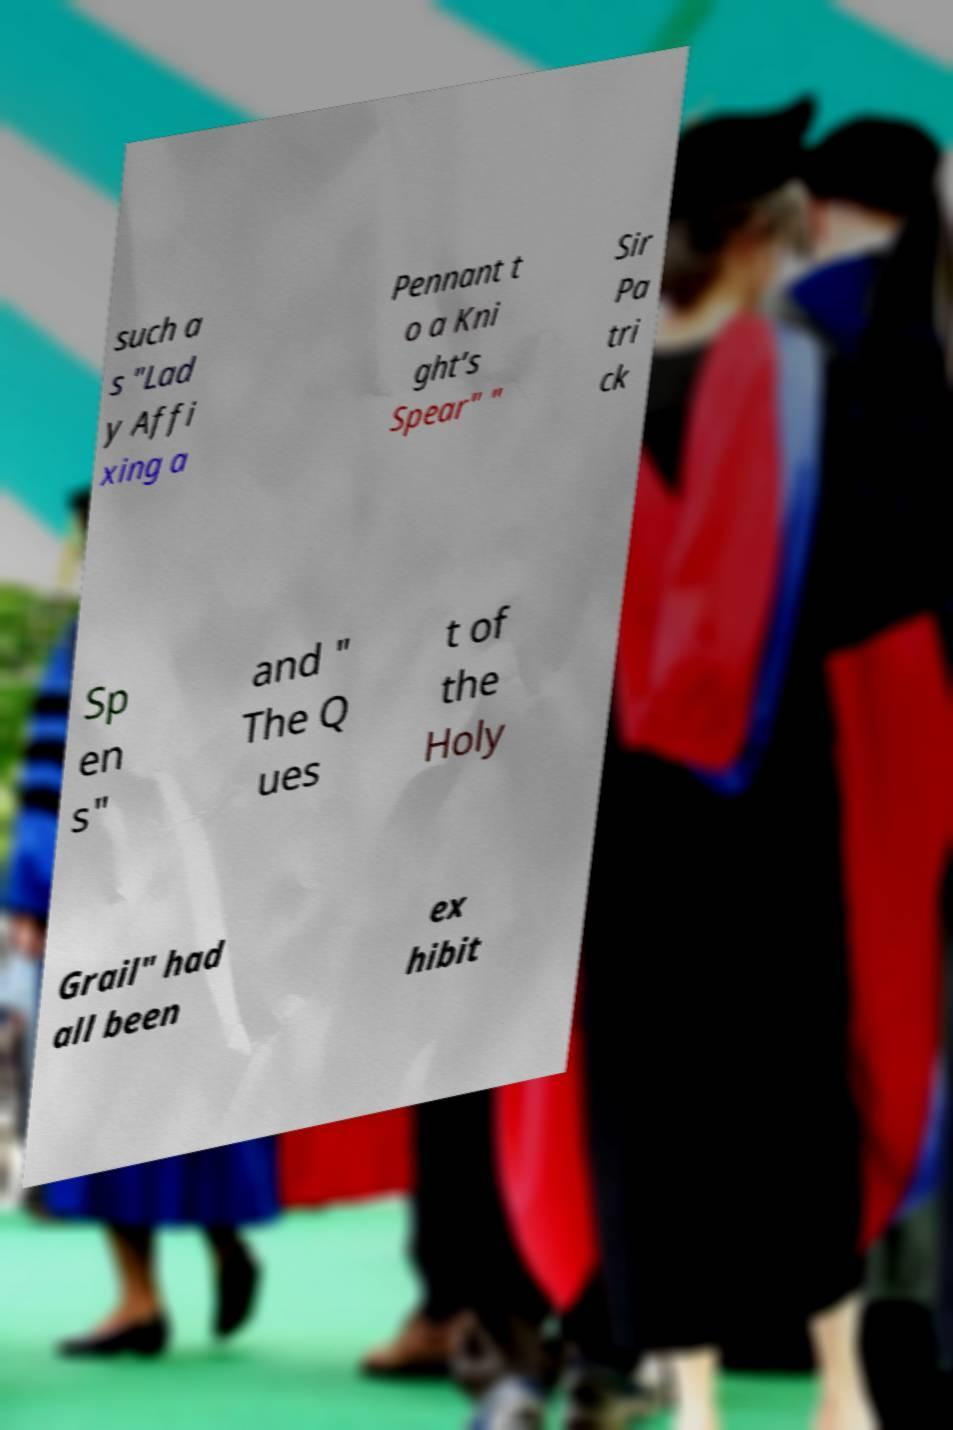I need the written content from this picture converted into text. Can you do that? such a s "Lad y Affi xing a Pennant t o a Kni ght’s Spear" " Sir Pa tri ck Sp en s" and " The Q ues t of the Holy Grail" had all been ex hibit 